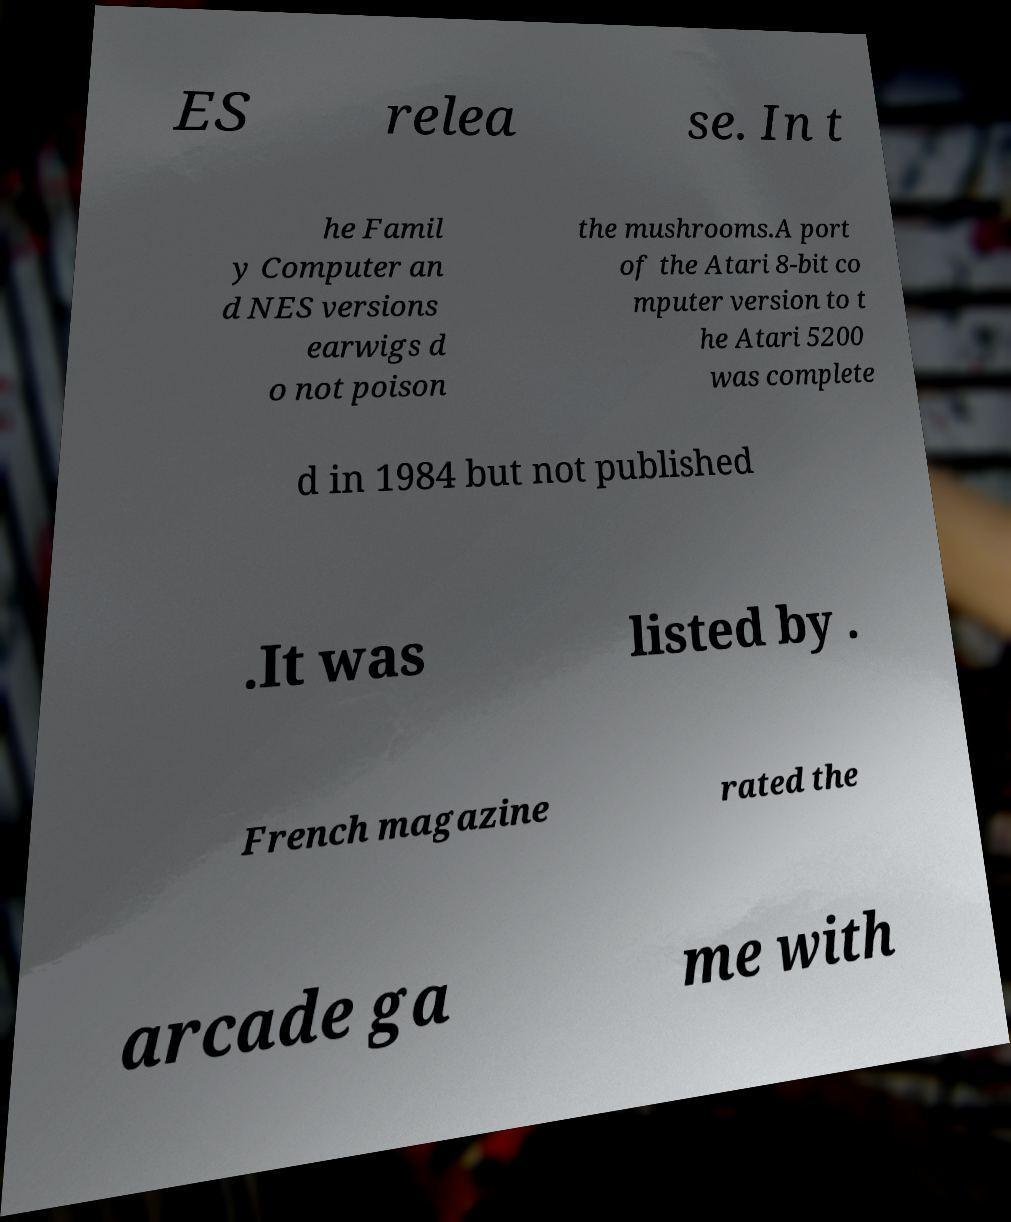Please read and relay the text visible in this image. What does it say? ES relea se. In t he Famil y Computer an d NES versions earwigs d o not poison the mushrooms.A port of the Atari 8-bit co mputer version to t he Atari 5200 was complete d in 1984 but not published .It was listed by . French magazine rated the arcade ga me with 